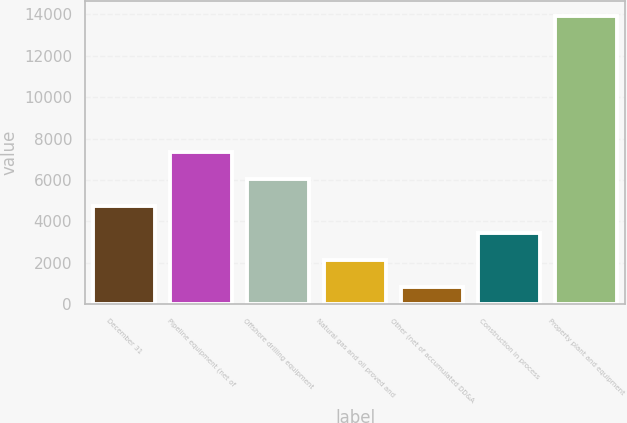Convert chart. <chart><loc_0><loc_0><loc_500><loc_500><bar_chart><fcel>December 31<fcel>Pipeline equipment (net of<fcel>Offshore drilling equipment<fcel>Natural gas and oil proved and<fcel>Other (net of accumulated DD&A<fcel>Construction in process<fcel>Property plant and equipment<nl><fcel>4751<fcel>7375<fcel>6063<fcel>2127<fcel>815<fcel>3439<fcel>13935<nl></chart> 